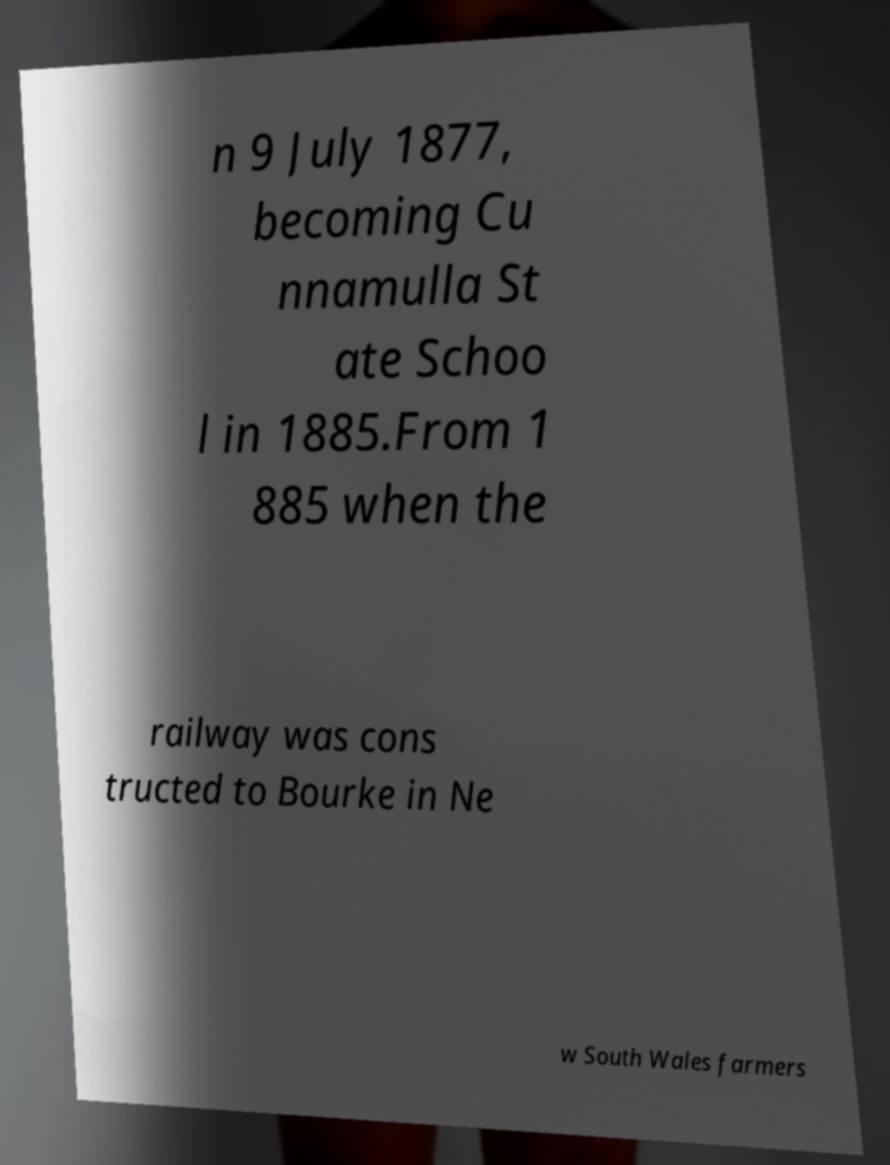There's text embedded in this image that I need extracted. Can you transcribe it verbatim? n 9 July 1877, becoming Cu nnamulla St ate Schoo l in 1885.From 1 885 when the railway was cons tructed to Bourke in Ne w South Wales farmers 